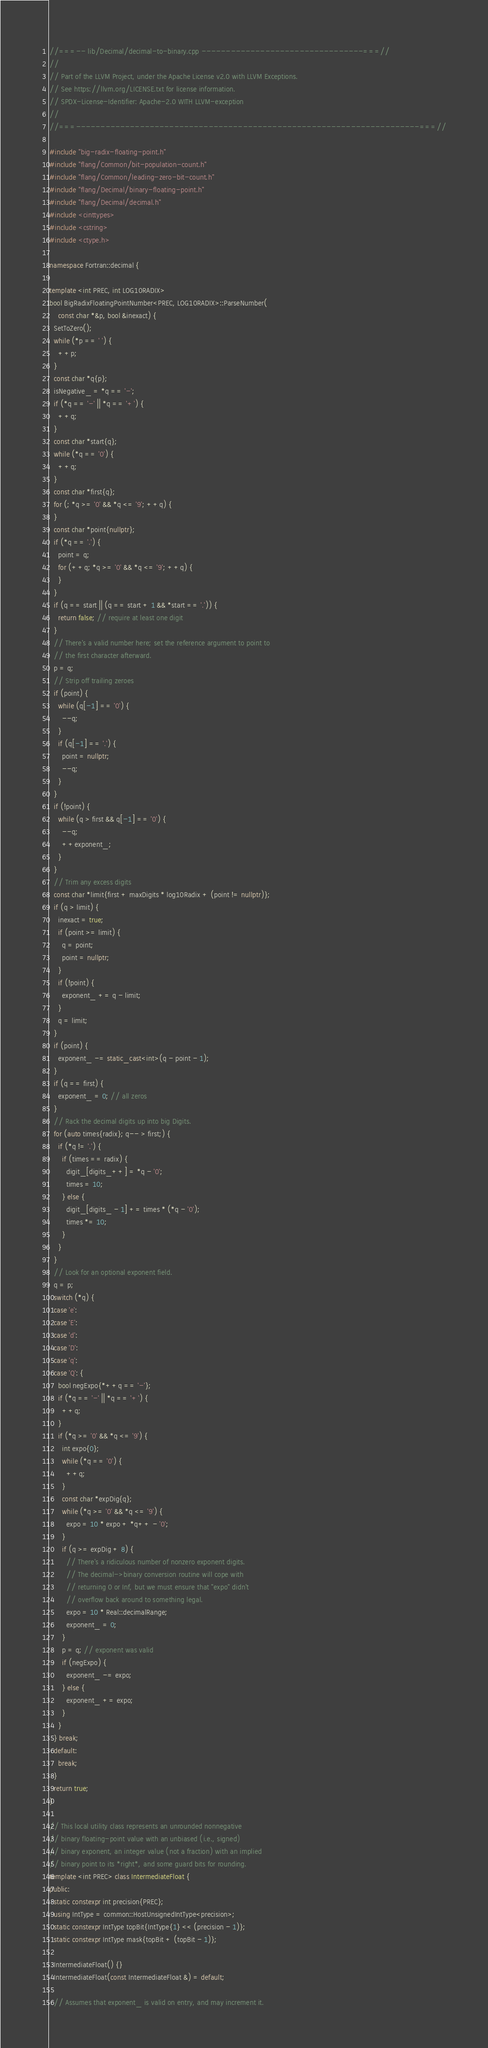Convert code to text. <code><loc_0><loc_0><loc_500><loc_500><_C++_>//===-- lib/Decimal/decimal-to-binary.cpp ---------------------------------===//
//
// Part of the LLVM Project, under the Apache License v2.0 with LLVM Exceptions.
// See https://llvm.org/LICENSE.txt for license information.
// SPDX-License-Identifier: Apache-2.0 WITH LLVM-exception
//
//===----------------------------------------------------------------------===//

#include "big-radix-floating-point.h"
#include "flang/Common/bit-population-count.h"
#include "flang/Common/leading-zero-bit-count.h"
#include "flang/Decimal/binary-floating-point.h"
#include "flang/Decimal/decimal.h"
#include <cinttypes>
#include <cstring>
#include <ctype.h>

namespace Fortran::decimal {

template <int PREC, int LOG10RADIX>
bool BigRadixFloatingPointNumber<PREC, LOG10RADIX>::ParseNumber(
    const char *&p, bool &inexact) {
  SetToZero();
  while (*p == ' ') {
    ++p;
  }
  const char *q{p};
  isNegative_ = *q == '-';
  if (*q == '-' || *q == '+') {
    ++q;
  }
  const char *start{q};
  while (*q == '0') {
    ++q;
  }
  const char *first{q};
  for (; *q >= '0' && *q <= '9'; ++q) {
  }
  const char *point{nullptr};
  if (*q == '.') {
    point = q;
    for (++q; *q >= '0' && *q <= '9'; ++q) {
    }
  }
  if (q == start || (q == start + 1 && *start == '.')) {
    return false; // require at least one digit
  }
  // There's a valid number here; set the reference argument to point to
  // the first character afterward.
  p = q;
  // Strip off trailing zeroes
  if (point) {
    while (q[-1] == '0') {
      --q;
    }
    if (q[-1] == '.') {
      point = nullptr;
      --q;
    }
  }
  if (!point) {
    while (q > first && q[-1] == '0') {
      --q;
      ++exponent_;
    }
  }
  // Trim any excess digits
  const char *limit{first + maxDigits * log10Radix + (point != nullptr)};
  if (q > limit) {
    inexact = true;
    if (point >= limit) {
      q = point;
      point = nullptr;
    }
    if (!point) {
      exponent_ += q - limit;
    }
    q = limit;
  }
  if (point) {
    exponent_ -= static_cast<int>(q - point - 1);
  }
  if (q == first) {
    exponent_ = 0; // all zeros
  }
  // Rack the decimal digits up into big Digits.
  for (auto times{radix}; q-- > first;) {
    if (*q != '.') {
      if (times == radix) {
        digit_[digits_++] = *q - '0';
        times = 10;
      } else {
        digit_[digits_ - 1] += times * (*q - '0');
        times *= 10;
      }
    }
  }
  // Look for an optional exponent field.
  q = p;
  switch (*q) {
  case 'e':
  case 'E':
  case 'd':
  case 'D':
  case 'q':
  case 'Q': {
    bool negExpo{*++q == '-'};
    if (*q == '-' || *q == '+') {
      ++q;
    }
    if (*q >= '0' && *q <= '9') {
      int expo{0};
      while (*q == '0') {
        ++q;
      }
      const char *expDig{q};
      while (*q >= '0' && *q <= '9') {
        expo = 10 * expo + *q++ - '0';
      }
      if (q >= expDig + 8) {
        // There's a ridiculous number of nonzero exponent digits.
        // The decimal->binary conversion routine will cope with
        // returning 0 or Inf, but we must ensure that "expo" didn't
        // overflow back around to something legal.
        expo = 10 * Real::decimalRange;
        exponent_ = 0;
      }
      p = q; // exponent was valid
      if (negExpo) {
        exponent_ -= expo;
      } else {
        exponent_ += expo;
      }
    }
  } break;
  default:
    break;
  }
  return true;
}

// This local utility class represents an unrounded nonnegative
// binary floating-point value with an unbiased (i.e., signed)
// binary exponent, an integer value (not a fraction) with an implied
// binary point to its *right*, and some guard bits for rounding.
template <int PREC> class IntermediateFloat {
public:
  static constexpr int precision{PREC};
  using IntType = common::HostUnsignedIntType<precision>;
  static constexpr IntType topBit{IntType{1} << (precision - 1)};
  static constexpr IntType mask{topBit + (topBit - 1)};

  IntermediateFloat() {}
  IntermediateFloat(const IntermediateFloat &) = default;

  // Assumes that exponent_ is valid on entry, and may increment it.</code> 